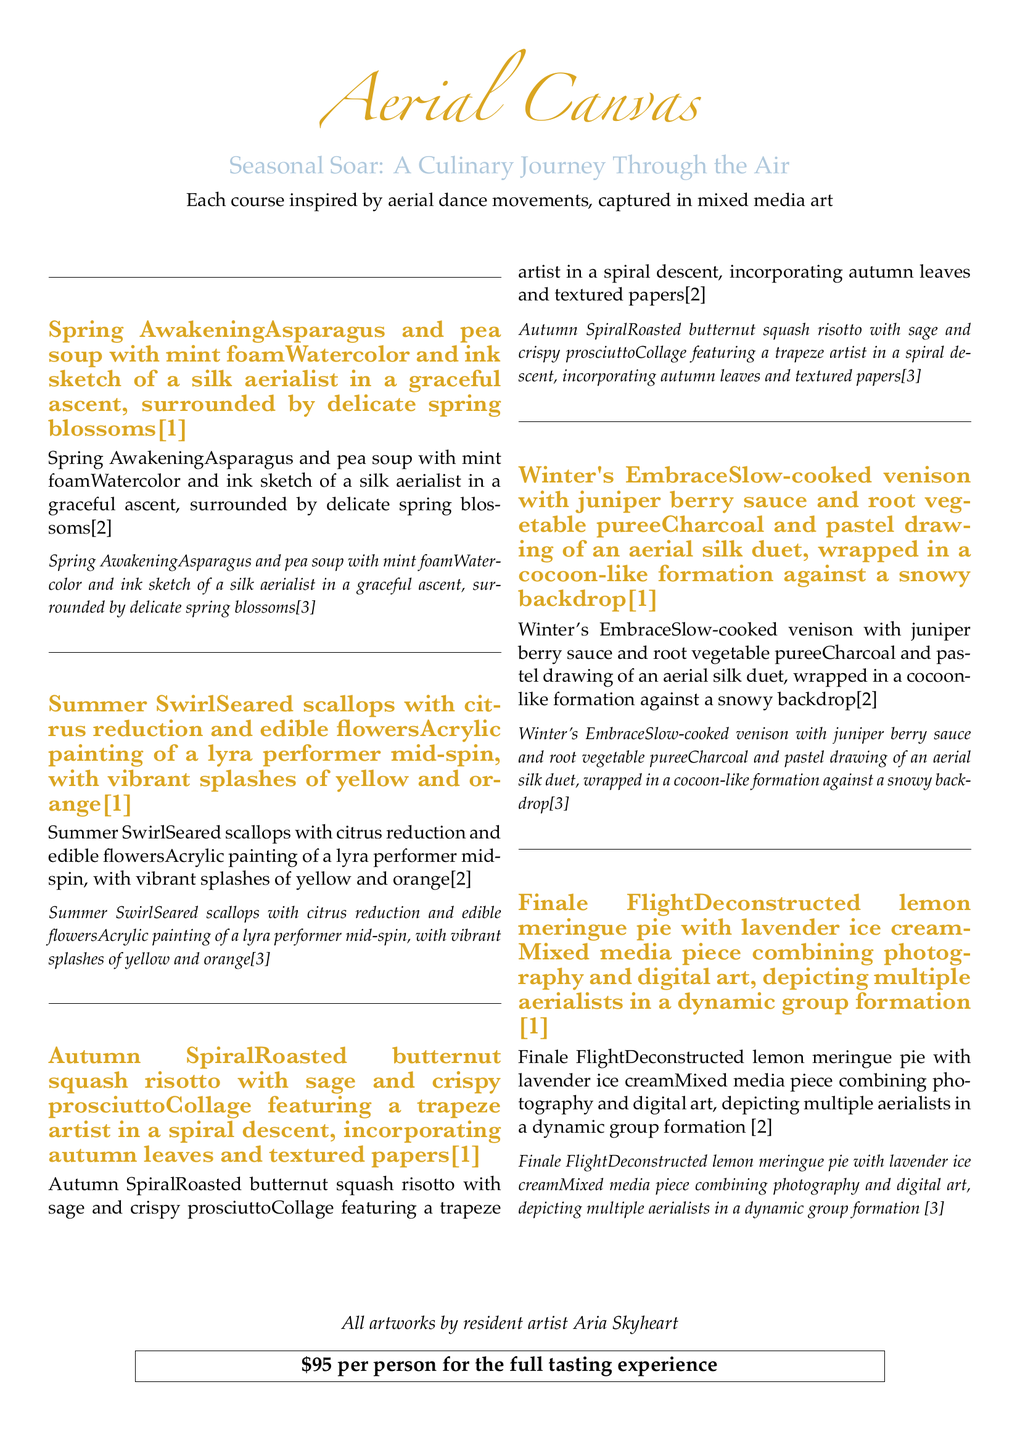What is the title of the menu? The title of the menu, prominently displayed, is "Aerial Canvas."
Answer: Aerial Canvas How much does the full tasting experience cost? The menu states the cost for the full tasting experience, which is highlighted in a box.
Answer: $95 per person What is the first course of the tasting menu? The first course, as listed in the menu, is named "Spring Awakening."
Answer: Spring Awakening Which artist created the artworks featured in the menu? The document credits the artworks to a specific artist mentioned at the bottom.
Answer: Aria Skyheart What type of dish is served in the "Autumn Spiral" course? The document describes the dish served in "Autumn Spiral" as roasted butternut squash risotto.
Answer: Roasted butternut squash risotto Which course features scallops? The course that features scallops is indicated in the menu and is "Summer Swirl."
Answer: Summer Swirl What artistic medium is used for the "Winter's Embrace" course artwork? The document specifies that a charcoal and pastel drawing is used for "Winter's Embrace."
Answer: Charcoal and pastel How many courses are included in the tasting menu? The document lists a total of five unique courses in the tasting menu.
Answer: Five 